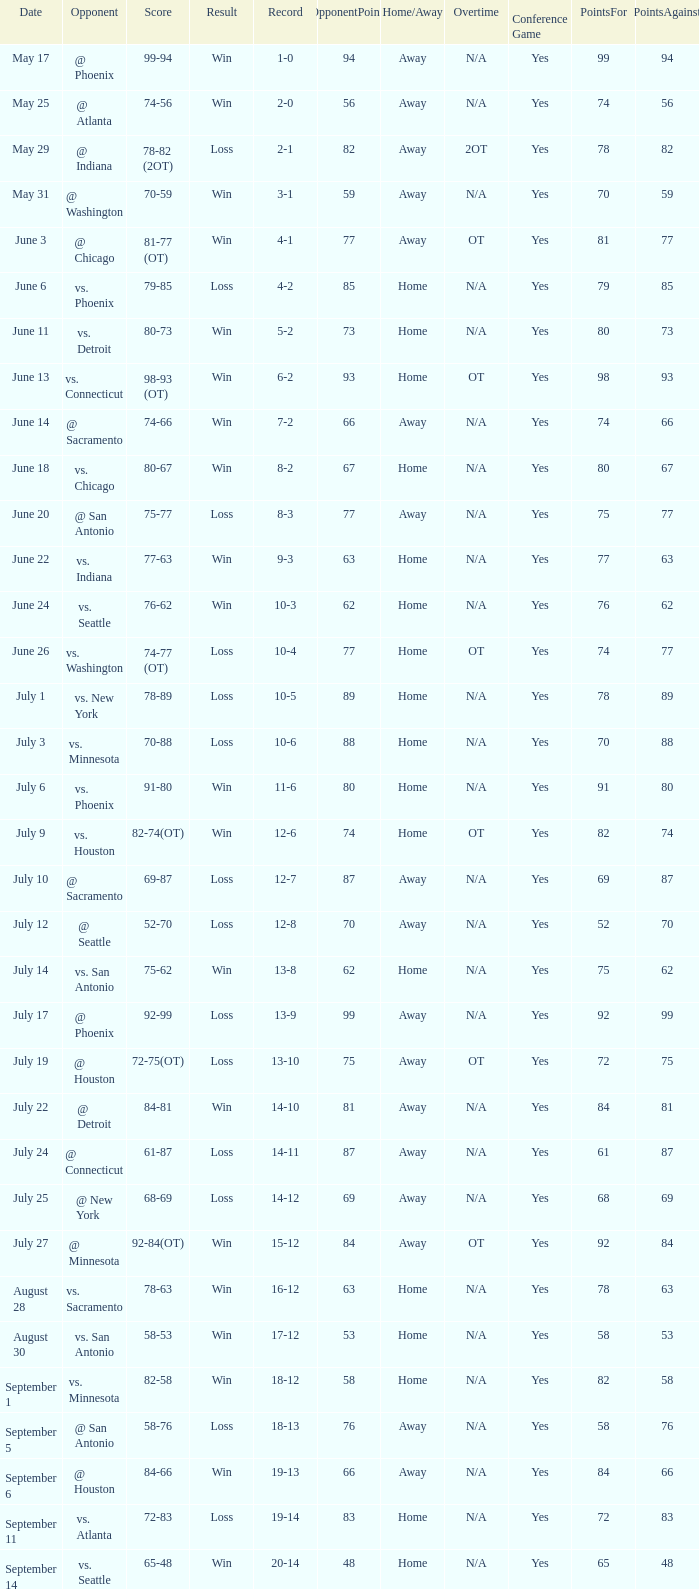What is the Opponent of the game with a Score of 74-66? @ Sacramento. 